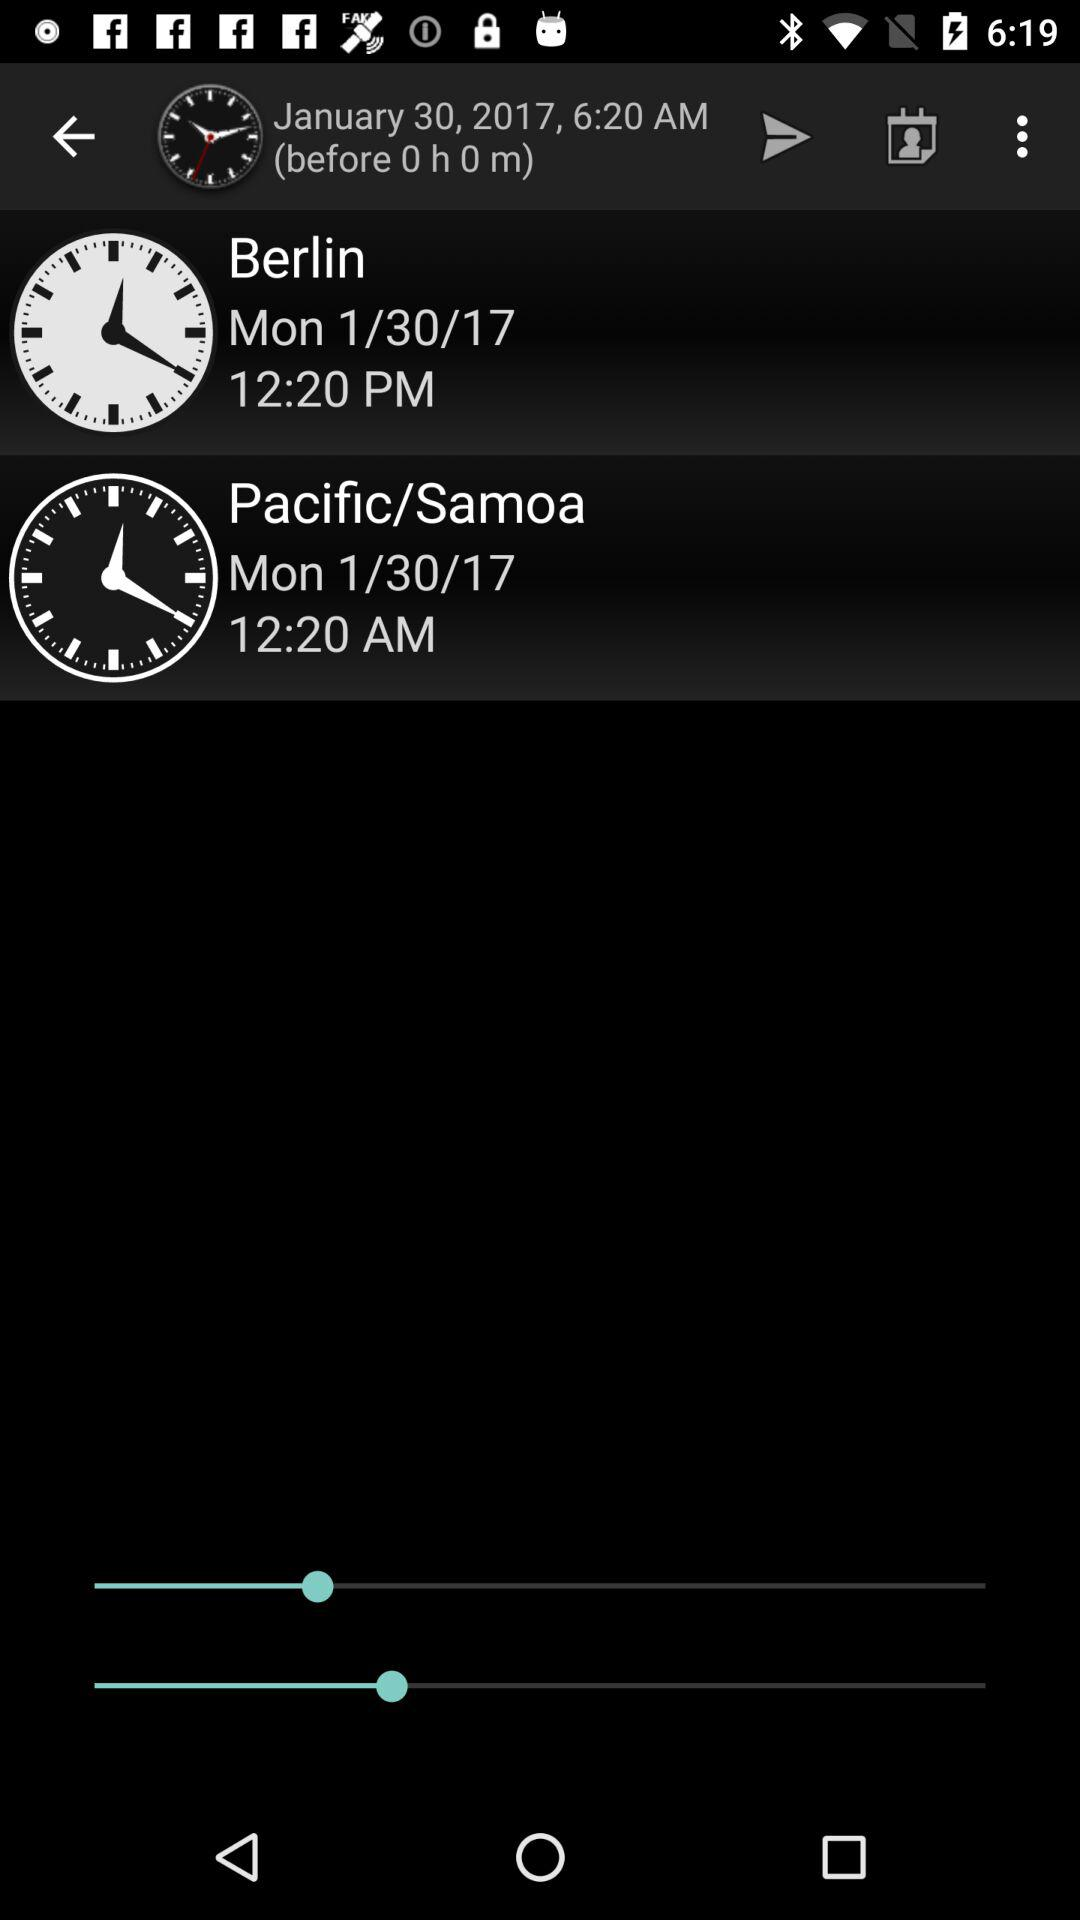What time is it in Berlin? It is 12:20 PM in Berlin. 